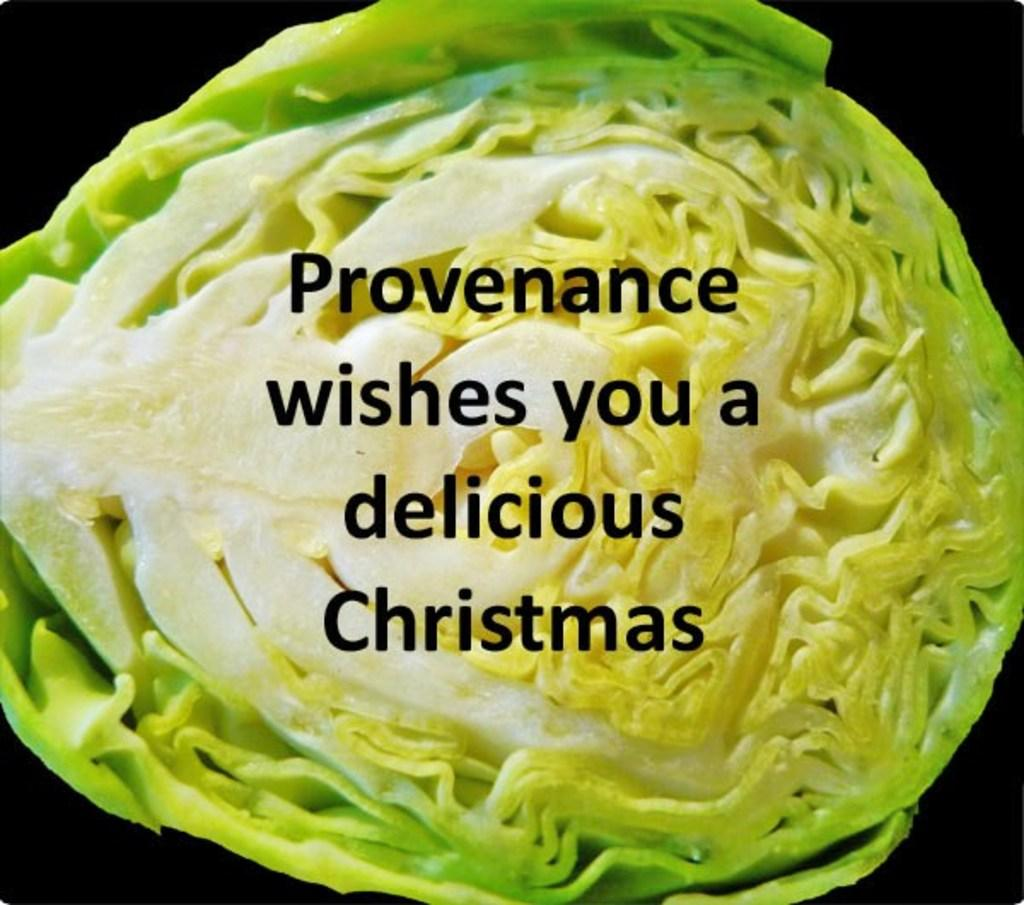What is the main feature of the image? There is text in the middle of the image. Can you describe the text in the image? Unfortunately, the details of the text cannot be determined from the provided facts. What else can be seen in the image besides the text? There is a food item in the background of the image. Can you describe the food item in the image? Unfortunately, the details of the food item cannot be determined from the provided facts. How many nails are used to stitch the regret in the image? There is no mention of nails, stitching, or regret in the image. These elements are not present in the image based on the provided facts. 